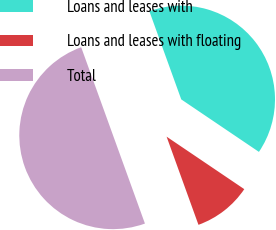Convert chart. <chart><loc_0><loc_0><loc_500><loc_500><pie_chart><fcel>Loans and leases with<fcel>Loans and leases with floating<fcel>Total<nl><fcel>39.98%<fcel>10.02%<fcel>50.0%<nl></chart> 